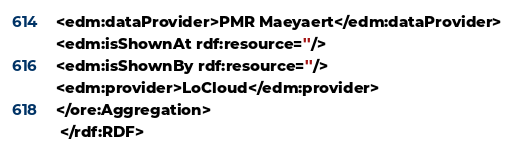<code> <loc_0><loc_0><loc_500><loc_500><_XML_><edm:dataProvider>PMR Maeyaert</edm:dataProvider>
<edm:isShownAt rdf:resource=''/>
<edm:isShownBy rdf:resource=''/>
<edm:provider>LoCloud</edm:provider>
</ore:Aggregation>
 </rdf:RDF>
</code> 